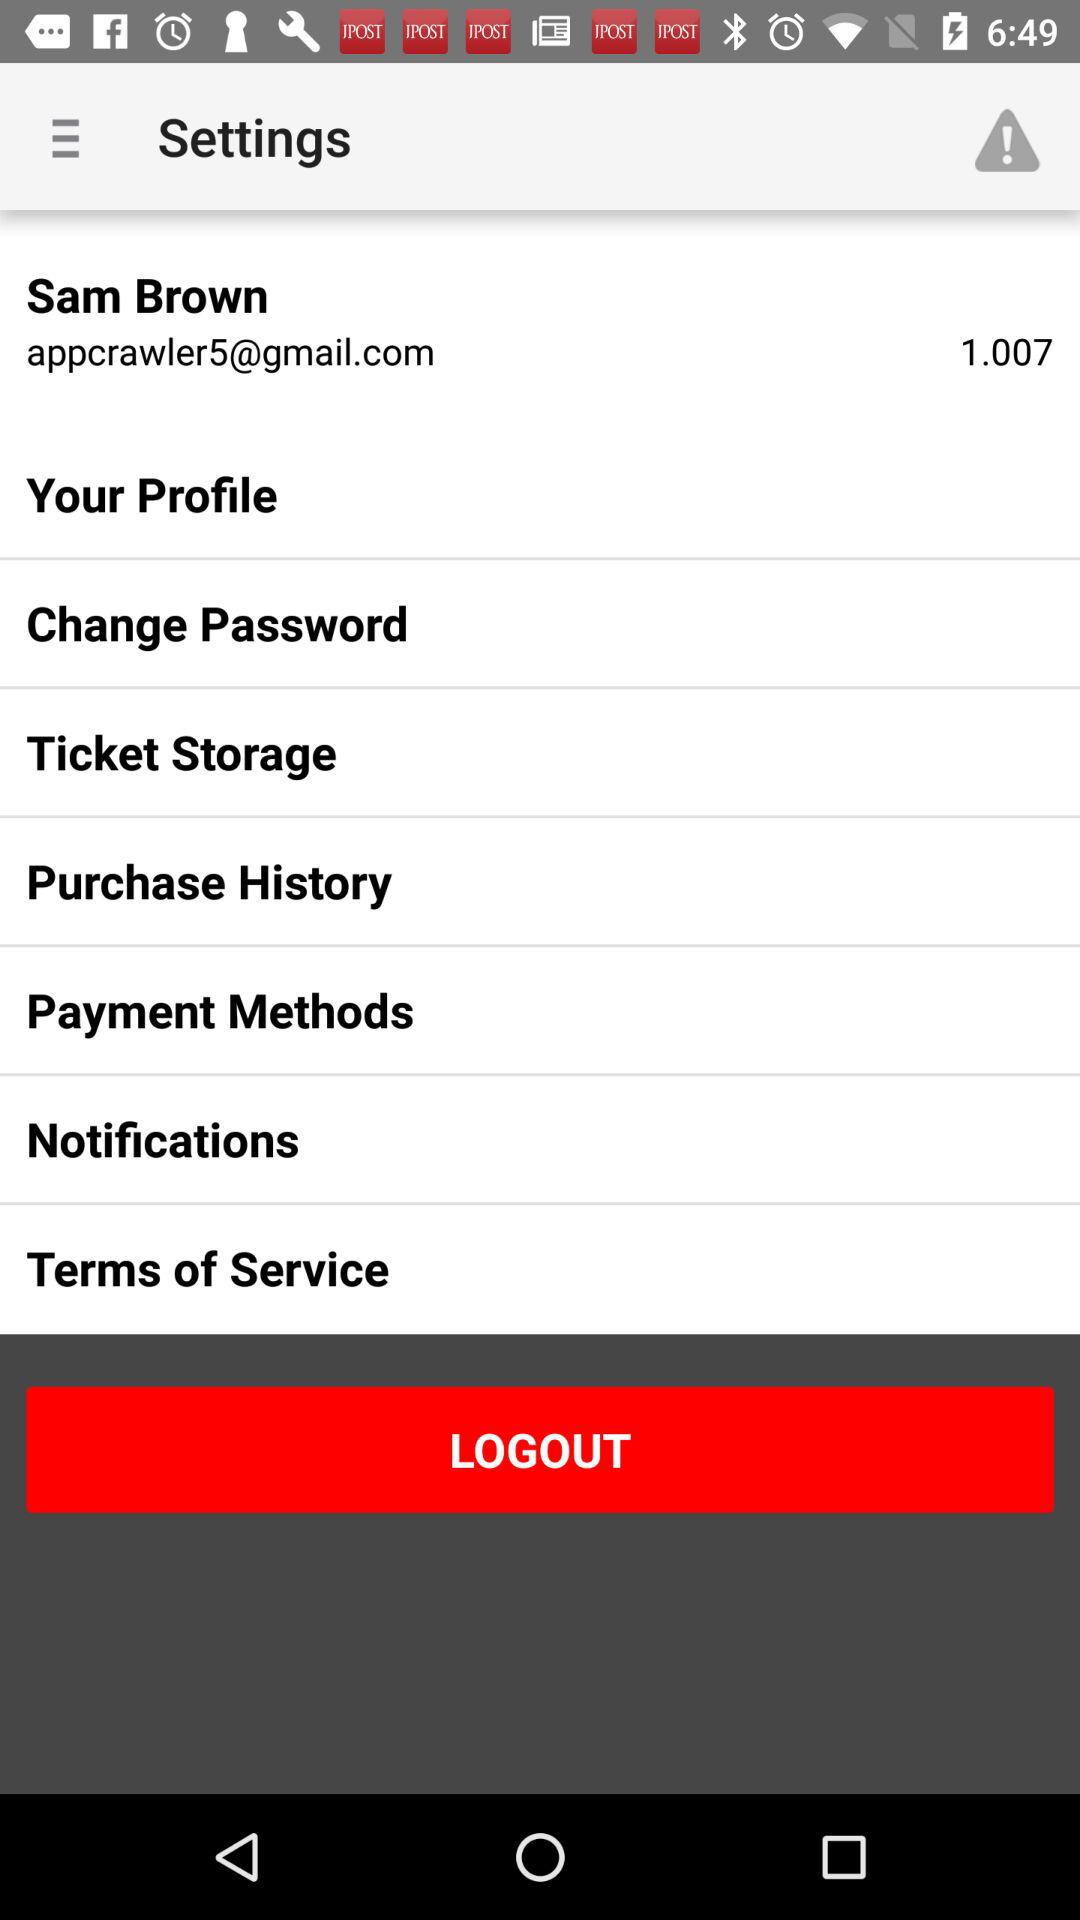What is the user name? The user name is Sam Brown. 